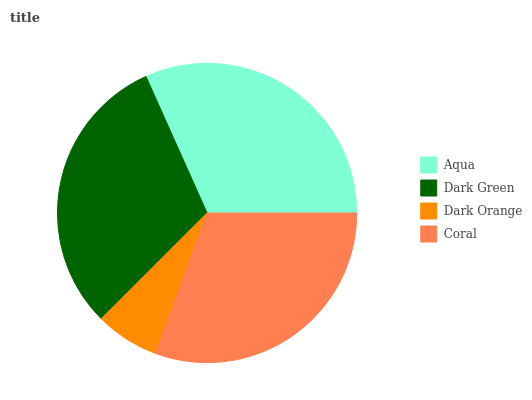Is Dark Orange the minimum?
Answer yes or no. Yes. Is Aqua the maximum?
Answer yes or no. Yes. Is Dark Green the minimum?
Answer yes or no. No. Is Dark Green the maximum?
Answer yes or no. No. Is Aqua greater than Dark Green?
Answer yes or no. Yes. Is Dark Green less than Aqua?
Answer yes or no. Yes. Is Dark Green greater than Aqua?
Answer yes or no. No. Is Aqua less than Dark Green?
Answer yes or no. No. Is Dark Green the high median?
Answer yes or no. Yes. Is Coral the low median?
Answer yes or no. Yes. Is Aqua the high median?
Answer yes or no. No. Is Dark Green the low median?
Answer yes or no. No. 